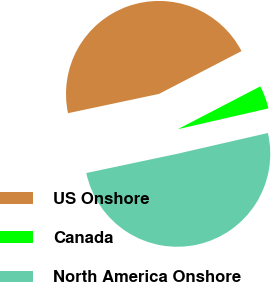Convert chart. <chart><loc_0><loc_0><loc_500><loc_500><pie_chart><fcel>US Onshore<fcel>Canada<fcel>North America Onshore<nl><fcel>45.7%<fcel>4.03%<fcel>50.27%<nl></chart> 